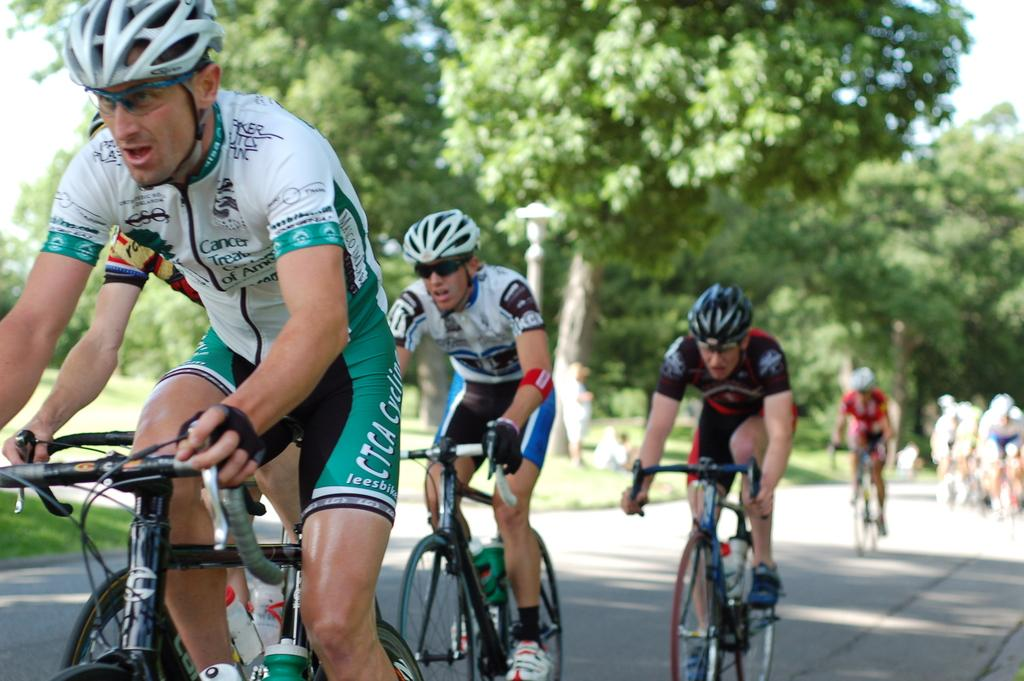What are the people in the image doing? The people in the image are riding bicycles on the road. What can be seen in the background of the image? There is grass, a pole, people, trees, and the sky visible in the background. Where are the dolls positioned in the image? There are no dolls present in the image. What is the position of the roof in the image? There is no roof present in the image. 